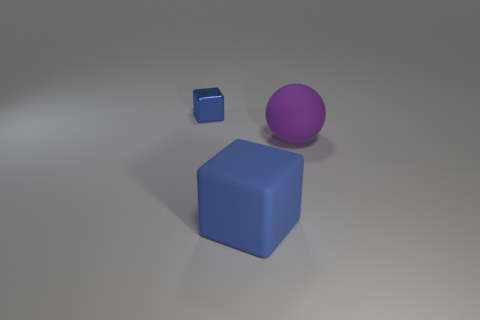Subtract 1 cubes. How many cubes are left? 1 Subtract all tiny blue objects. Subtract all large rubber cubes. How many objects are left? 1 Add 3 tiny cubes. How many tiny cubes are left? 4 Add 3 large purple rubber spheres. How many large purple rubber spheres exist? 4 Add 2 metal objects. How many objects exist? 5 Subtract 0 red spheres. How many objects are left? 3 Subtract all spheres. How many objects are left? 2 Subtract all brown balls. Subtract all red cylinders. How many balls are left? 1 Subtract all yellow blocks. How many red spheres are left? 0 